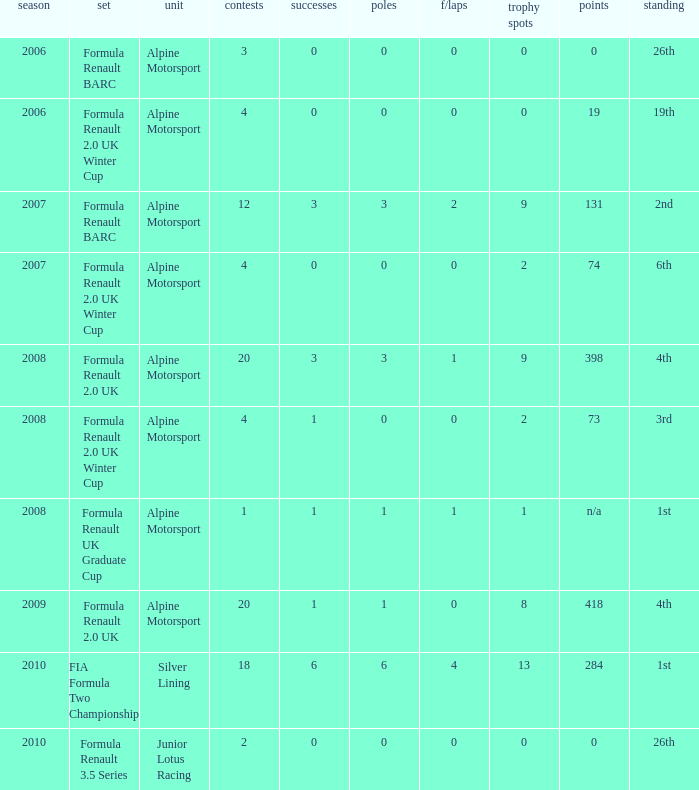What was the earliest season where podium was 9? 2007.0. Can you give me this table as a dict? {'header': ['season', 'set', 'unit', 'contests', 'successes', 'poles', 'f/laps', 'trophy spots', 'points', 'standing'], 'rows': [['2006', 'Formula Renault BARC', 'Alpine Motorsport', '3', '0', '0', '0', '0', '0', '26th'], ['2006', 'Formula Renault 2.0 UK Winter Cup', 'Alpine Motorsport', '4', '0', '0', '0', '0', '19', '19th'], ['2007', 'Formula Renault BARC', 'Alpine Motorsport', '12', '3', '3', '2', '9', '131', '2nd'], ['2007', 'Formula Renault 2.0 UK Winter Cup', 'Alpine Motorsport', '4', '0', '0', '0', '2', '74', '6th'], ['2008', 'Formula Renault 2.0 UK', 'Alpine Motorsport', '20', '3', '3', '1', '9', '398', '4th'], ['2008', 'Formula Renault 2.0 UK Winter Cup', 'Alpine Motorsport', '4', '1', '0', '0', '2', '73', '3rd'], ['2008', 'Formula Renault UK Graduate Cup', 'Alpine Motorsport', '1', '1', '1', '1', '1', 'n/a', '1st'], ['2009', 'Formula Renault 2.0 UK', 'Alpine Motorsport', '20', '1', '1', '0', '8', '418', '4th'], ['2010', 'FIA Formula Two Championship', 'Silver Lining', '18', '6', '6', '4', '13', '284', '1st'], ['2010', 'Formula Renault 3.5 Series', 'Junior Lotus Racing', '2', '0', '0', '0', '0', '0', '26th']]} 